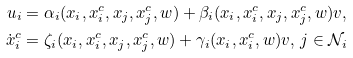Convert formula to latex. <formula><loc_0><loc_0><loc_500><loc_500>u _ { i } & = \alpha _ { i } ( x _ { i } , x ^ { c } _ { i } , x _ { j } , x ^ { c } _ { j } , w ) + \beta _ { i } ( x _ { i } , x ^ { c } _ { i } , x _ { j } , x ^ { c } _ { j } , w ) v , \\ \dot { x } ^ { c } _ { i } & = \zeta _ { i } ( x _ { i } , x ^ { c } _ { i } , x _ { j } , x ^ { c } _ { j } , w ) + \gamma _ { i } ( x _ { i } , x ^ { c } _ { i } , w ) v , \, j \in \mathcal { N } _ { i }</formula> 